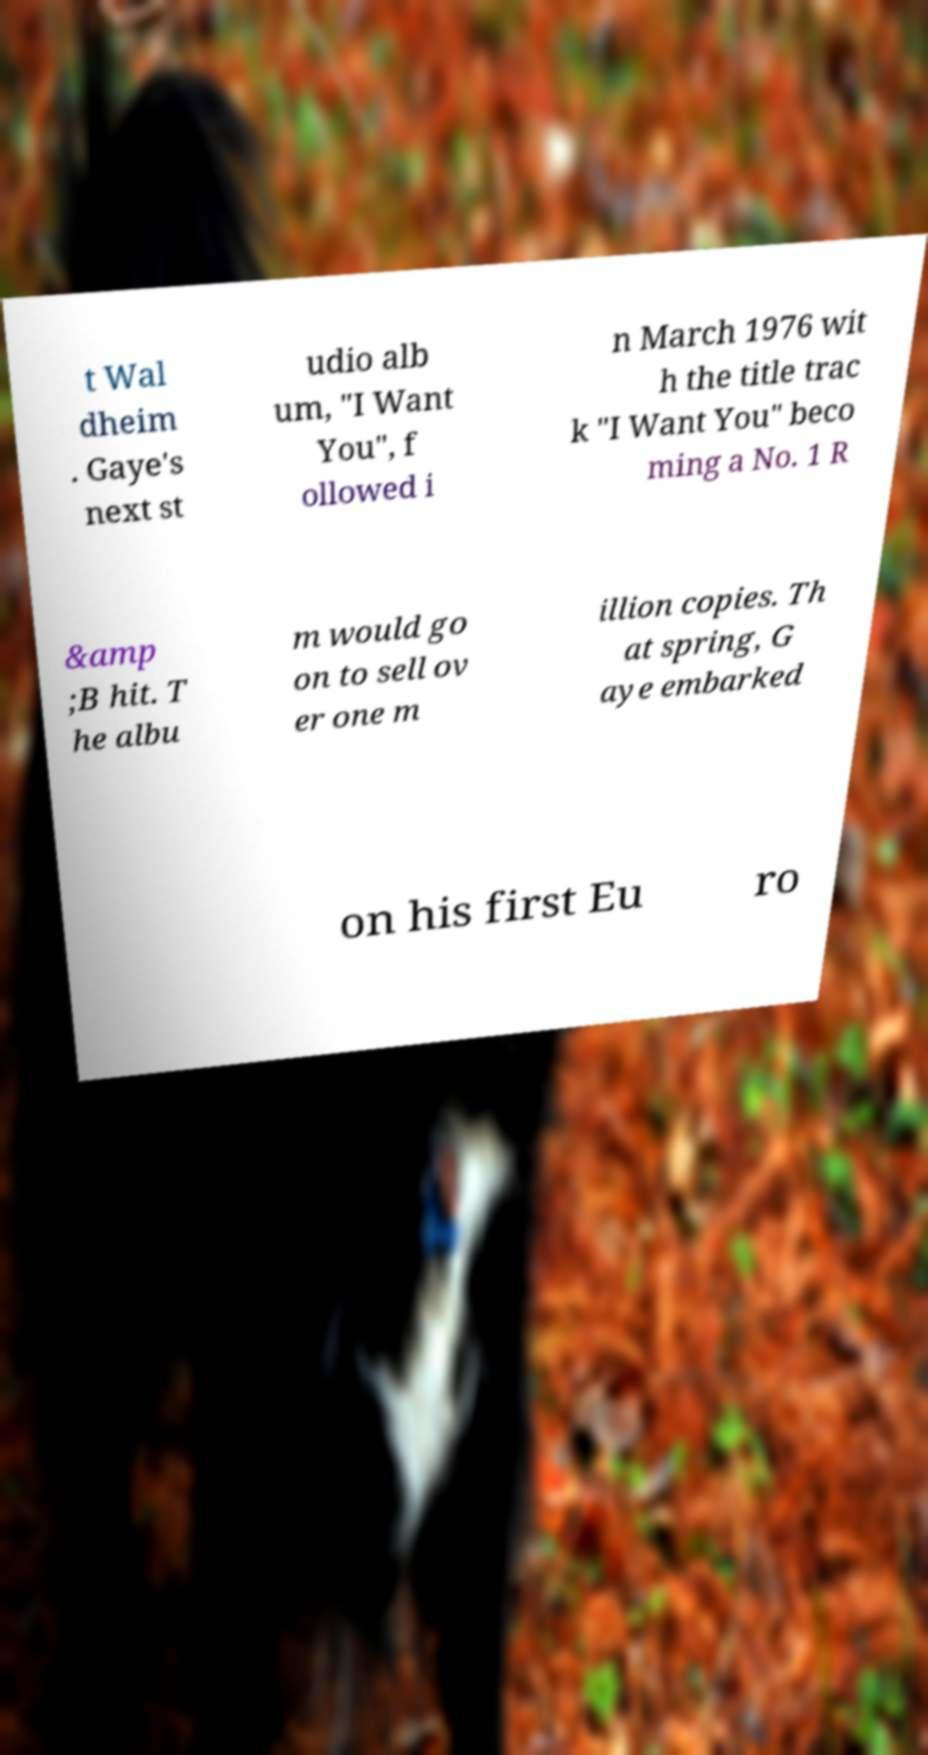Could you assist in decoding the text presented in this image and type it out clearly? t Wal dheim . Gaye's next st udio alb um, "I Want You", f ollowed i n March 1976 wit h the title trac k "I Want You" beco ming a No. 1 R &amp ;B hit. T he albu m would go on to sell ov er one m illion copies. Th at spring, G aye embarked on his first Eu ro 